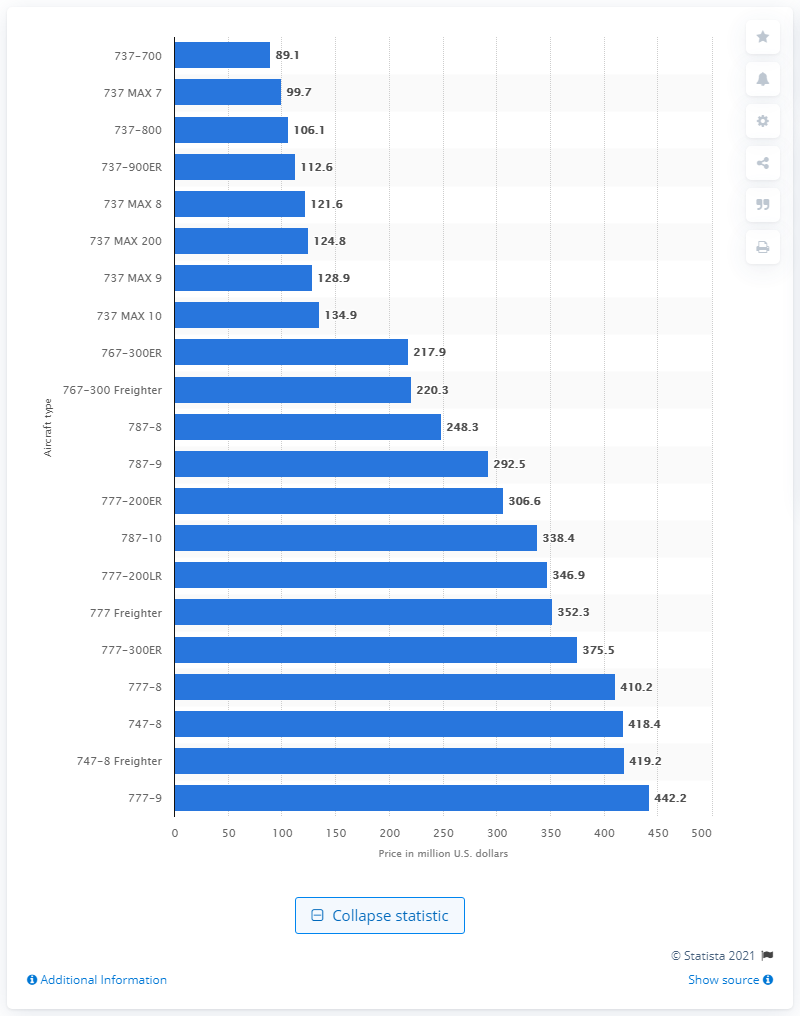Mention a couple of crucial points in this snapshot. The average price of the Boeing 777-9 is approximately 442.2. 